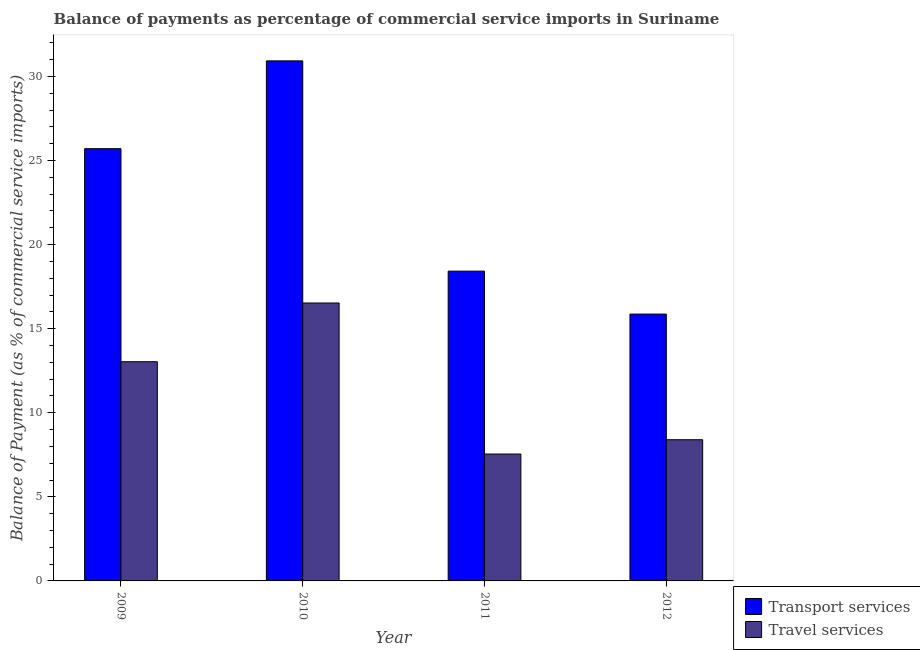How many different coloured bars are there?
Provide a succinct answer. 2. How many groups of bars are there?
Your answer should be very brief. 4. Are the number of bars per tick equal to the number of legend labels?
Your response must be concise. Yes. How many bars are there on the 1st tick from the left?
Provide a short and direct response. 2. What is the balance of payments of travel services in 2011?
Provide a short and direct response. 7.54. Across all years, what is the maximum balance of payments of travel services?
Offer a terse response. 16.53. Across all years, what is the minimum balance of payments of travel services?
Offer a very short reply. 7.54. What is the total balance of payments of travel services in the graph?
Give a very brief answer. 45.5. What is the difference between the balance of payments of travel services in 2009 and that in 2011?
Offer a terse response. 5.49. What is the difference between the balance of payments of transport services in 2010 and the balance of payments of travel services in 2009?
Provide a short and direct response. 5.22. What is the average balance of payments of travel services per year?
Keep it short and to the point. 11.38. What is the ratio of the balance of payments of transport services in 2010 to that in 2011?
Give a very brief answer. 1.68. What is the difference between the highest and the second highest balance of payments of travel services?
Your answer should be compact. 3.49. What is the difference between the highest and the lowest balance of payments of travel services?
Your answer should be very brief. 8.98. What does the 2nd bar from the left in 2011 represents?
Your answer should be compact. Travel services. What does the 2nd bar from the right in 2012 represents?
Ensure brevity in your answer.  Transport services. What is the difference between two consecutive major ticks on the Y-axis?
Provide a short and direct response. 5. Are the values on the major ticks of Y-axis written in scientific E-notation?
Provide a succinct answer. No. How are the legend labels stacked?
Make the answer very short. Vertical. What is the title of the graph?
Provide a short and direct response. Balance of payments as percentage of commercial service imports in Suriname. Does "Sanitation services" appear as one of the legend labels in the graph?
Ensure brevity in your answer.  No. What is the label or title of the Y-axis?
Provide a short and direct response. Balance of Payment (as % of commercial service imports). What is the Balance of Payment (as % of commercial service imports) in Transport services in 2009?
Provide a short and direct response. 25.7. What is the Balance of Payment (as % of commercial service imports) in Travel services in 2009?
Make the answer very short. 13.03. What is the Balance of Payment (as % of commercial service imports) in Transport services in 2010?
Ensure brevity in your answer.  30.92. What is the Balance of Payment (as % of commercial service imports) of Travel services in 2010?
Your answer should be very brief. 16.53. What is the Balance of Payment (as % of commercial service imports) of Transport services in 2011?
Offer a very short reply. 18.42. What is the Balance of Payment (as % of commercial service imports) in Travel services in 2011?
Keep it short and to the point. 7.54. What is the Balance of Payment (as % of commercial service imports) in Transport services in 2012?
Your response must be concise. 15.87. What is the Balance of Payment (as % of commercial service imports) in Travel services in 2012?
Offer a very short reply. 8.4. Across all years, what is the maximum Balance of Payment (as % of commercial service imports) of Transport services?
Your response must be concise. 30.92. Across all years, what is the maximum Balance of Payment (as % of commercial service imports) of Travel services?
Provide a succinct answer. 16.53. Across all years, what is the minimum Balance of Payment (as % of commercial service imports) of Transport services?
Offer a terse response. 15.87. Across all years, what is the minimum Balance of Payment (as % of commercial service imports) in Travel services?
Provide a succinct answer. 7.54. What is the total Balance of Payment (as % of commercial service imports) in Transport services in the graph?
Make the answer very short. 90.91. What is the total Balance of Payment (as % of commercial service imports) of Travel services in the graph?
Offer a very short reply. 45.5. What is the difference between the Balance of Payment (as % of commercial service imports) in Transport services in 2009 and that in 2010?
Offer a very short reply. -5.22. What is the difference between the Balance of Payment (as % of commercial service imports) in Travel services in 2009 and that in 2010?
Your answer should be compact. -3.49. What is the difference between the Balance of Payment (as % of commercial service imports) of Transport services in 2009 and that in 2011?
Ensure brevity in your answer.  7.28. What is the difference between the Balance of Payment (as % of commercial service imports) in Travel services in 2009 and that in 2011?
Your response must be concise. 5.49. What is the difference between the Balance of Payment (as % of commercial service imports) of Transport services in 2009 and that in 2012?
Give a very brief answer. 9.84. What is the difference between the Balance of Payment (as % of commercial service imports) in Travel services in 2009 and that in 2012?
Ensure brevity in your answer.  4.64. What is the difference between the Balance of Payment (as % of commercial service imports) of Transport services in 2010 and that in 2011?
Provide a succinct answer. 12.5. What is the difference between the Balance of Payment (as % of commercial service imports) of Travel services in 2010 and that in 2011?
Make the answer very short. 8.98. What is the difference between the Balance of Payment (as % of commercial service imports) in Transport services in 2010 and that in 2012?
Your answer should be very brief. 15.06. What is the difference between the Balance of Payment (as % of commercial service imports) of Travel services in 2010 and that in 2012?
Provide a succinct answer. 8.13. What is the difference between the Balance of Payment (as % of commercial service imports) of Transport services in 2011 and that in 2012?
Ensure brevity in your answer.  2.55. What is the difference between the Balance of Payment (as % of commercial service imports) of Travel services in 2011 and that in 2012?
Give a very brief answer. -0.85. What is the difference between the Balance of Payment (as % of commercial service imports) in Transport services in 2009 and the Balance of Payment (as % of commercial service imports) in Travel services in 2010?
Your answer should be very brief. 9.18. What is the difference between the Balance of Payment (as % of commercial service imports) in Transport services in 2009 and the Balance of Payment (as % of commercial service imports) in Travel services in 2011?
Give a very brief answer. 18.16. What is the difference between the Balance of Payment (as % of commercial service imports) of Transport services in 2009 and the Balance of Payment (as % of commercial service imports) of Travel services in 2012?
Ensure brevity in your answer.  17.31. What is the difference between the Balance of Payment (as % of commercial service imports) in Transport services in 2010 and the Balance of Payment (as % of commercial service imports) in Travel services in 2011?
Your response must be concise. 23.38. What is the difference between the Balance of Payment (as % of commercial service imports) in Transport services in 2010 and the Balance of Payment (as % of commercial service imports) in Travel services in 2012?
Make the answer very short. 22.53. What is the difference between the Balance of Payment (as % of commercial service imports) in Transport services in 2011 and the Balance of Payment (as % of commercial service imports) in Travel services in 2012?
Offer a terse response. 10.03. What is the average Balance of Payment (as % of commercial service imports) of Transport services per year?
Keep it short and to the point. 22.73. What is the average Balance of Payment (as % of commercial service imports) in Travel services per year?
Ensure brevity in your answer.  11.38. In the year 2009, what is the difference between the Balance of Payment (as % of commercial service imports) in Transport services and Balance of Payment (as % of commercial service imports) in Travel services?
Make the answer very short. 12.67. In the year 2010, what is the difference between the Balance of Payment (as % of commercial service imports) in Transport services and Balance of Payment (as % of commercial service imports) in Travel services?
Keep it short and to the point. 14.4. In the year 2011, what is the difference between the Balance of Payment (as % of commercial service imports) in Transport services and Balance of Payment (as % of commercial service imports) in Travel services?
Provide a short and direct response. 10.88. In the year 2012, what is the difference between the Balance of Payment (as % of commercial service imports) of Transport services and Balance of Payment (as % of commercial service imports) of Travel services?
Ensure brevity in your answer.  7.47. What is the ratio of the Balance of Payment (as % of commercial service imports) in Transport services in 2009 to that in 2010?
Your response must be concise. 0.83. What is the ratio of the Balance of Payment (as % of commercial service imports) in Travel services in 2009 to that in 2010?
Your answer should be very brief. 0.79. What is the ratio of the Balance of Payment (as % of commercial service imports) in Transport services in 2009 to that in 2011?
Your response must be concise. 1.4. What is the ratio of the Balance of Payment (as % of commercial service imports) in Travel services in 2009 to that in 2011?
Provide a succinct answer. 1.73. What is the ratio of the Balance of Payment (as % of commercial service imports) of Transport services in 2009 to that in 2012?
Offer a terse response. 1.62. What is the ratio of the Balance of Payment (as % of commercial service imports) in Travel services in 2009 to that in 2012?
Your answer should be compact. 1.55. What is the ratio of the Balance of Payment (as % of commercial service imports) in Transport services in 2010 to that in 2011?
Keep it short and to the point. 1.68. What is the ratio of the Balance of Payment (as % of commercial service imports) in Travel services in 2010 to that in 2011?
Make the answer very short. 2.19. What is the ratio of the Balance of Payment (as % of commercial service imports) of Transport services in 2010 to that in 2012?
Your answer should be compact. 1.95. What is the ratio of the Balance of Payment (as % of commercial service imports) in Travel services in 2010 to that in 2012?
Make the answer very short. 1.97. What is the ratio of the Balance of Payment (as % of commercial service imports) in Transport services in 2011 to that in 2012?
Offer a terse response. 1.16. What is the ratio of the Balance of Payment (as % of commercial service imports) of Travel services in 2011 to that in 2012?
Give a very brief answer. 0.9. What is the difference between the highest and the second highest Balance of Payment (as % of commercial service imports) in Transport services?
Make the answer very short. 5.22. What is the difference between the highest and the second highest Balance of Payment (as % of commercial service imports) in Travel services?
Your answer should be compact. 3.49. What is the difference between the highest and the lowest Balance of Payment (as % of commercial service imports) of Transport services?
Your response must be concise. 15.06. What is the difference between the highest and the lowest Balance of Payment (as % of commercial service imports) in Travel services?
Make the answer very short. 8.98. 